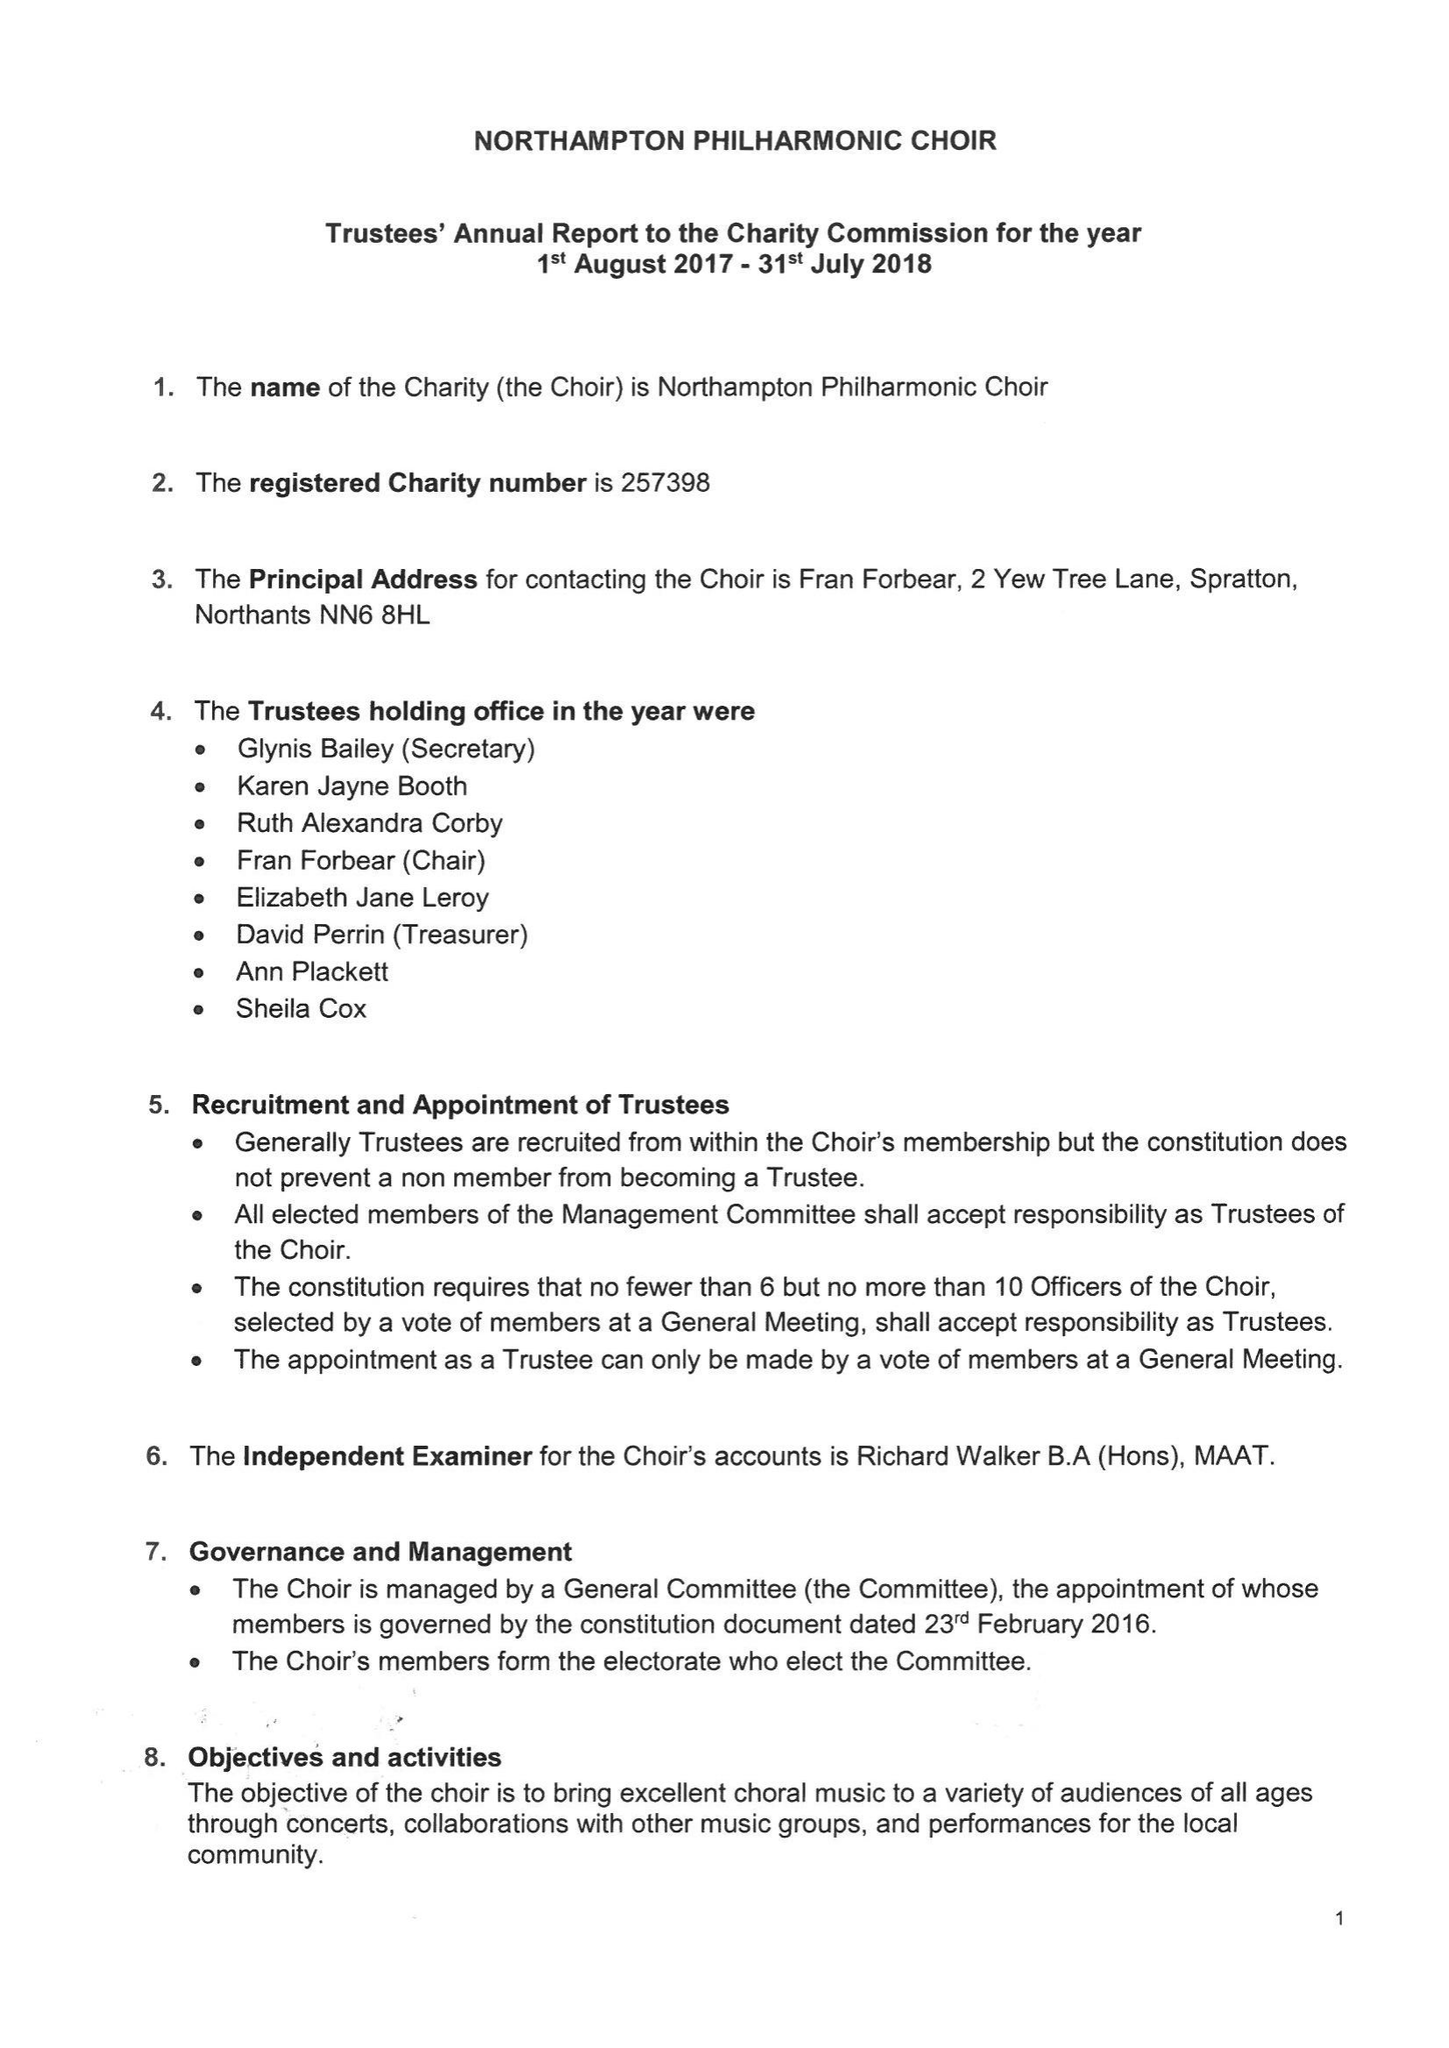What is the value for the address__street_line?
Answer the question using a single word or phrase. 2 YEW TREE LANE 